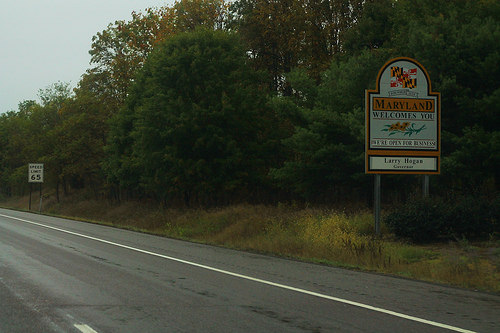<image>
Is there a plants to the right of the road? Yes. From this viewpoint, the plants is positioned to the right side relative to the road. 